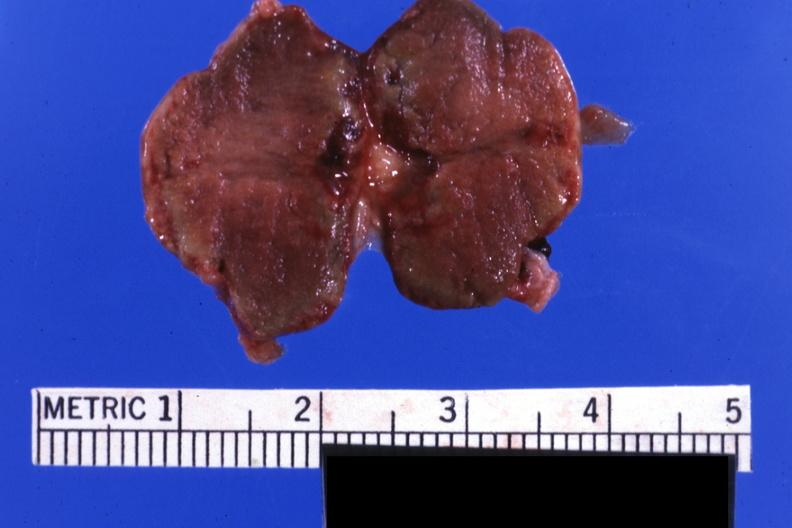s amyloidosis present?
Answer the question using a single word or phrase. No 